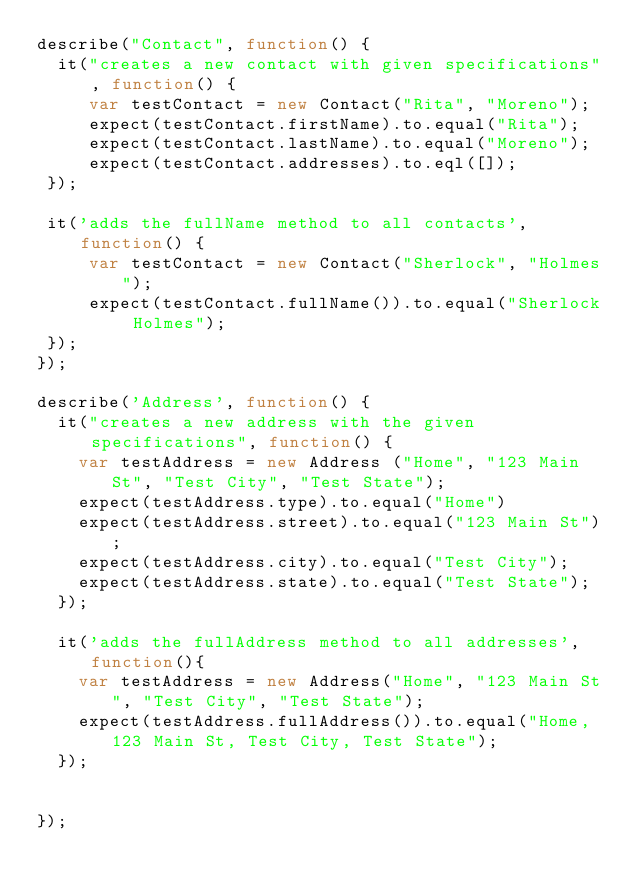<code> <loc_0><loc_0><loc_500><loc_500><_JavaScript_>describe("Contact", function() {
  it("creates a new contact with given specifications", function() {
     var testContact = new Contact("Rita", "Moreno");
     expect(testContact.firstName).to.equal("Rita");
     expect(testContact.lastName).to.equal("Moreno");
     expect(testContact.addresses).to.eql([]);
 });

 it('adds the fullName method to all contacts', function() {
     var testContact = new Contact("Sherlock", "Holmes");
     expect(testContact.fullName()).to.equal("Sherlock Holmes");
 });
});

describe('Address', function() {
  it("creates a new address with the given specifications", function() {
    var testAddress = new Address ("Home", "123 Main St", "Test City", "Test State");
    expect(testAddress.type).to.equal("Home")
    expect(testAddress.street).to.equal("123 Main St");
    expect(testAddress.city).to.equal("Test City");
    expect(testAddress.state).to.equal("Test State");
  });

  it('adds the fullAddress method to all addresses', function(){
    var testAddress = new Address("Home", "123 Main St", "Test City", "Test State");
    expect(testAddress.fullAddress()).to.equal("Home, 123 Main St, Test City, Test State");
  });


});
</code> 